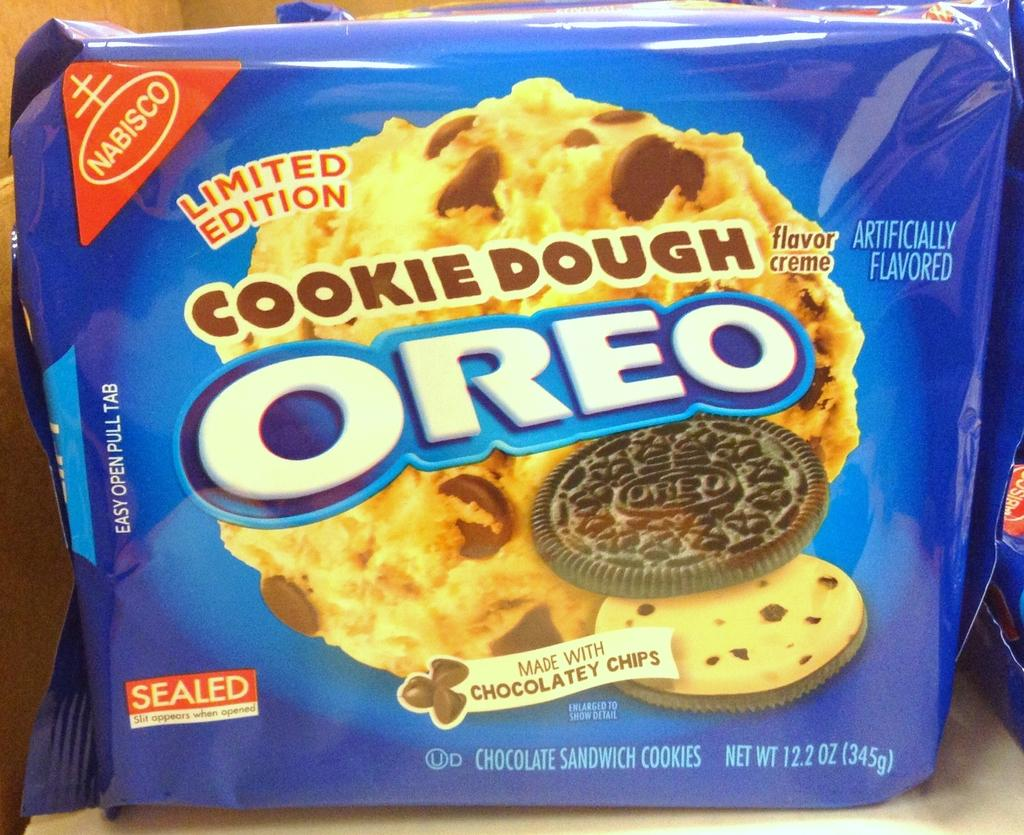What is: What is the main subject of the image? The main subject of the image is an Oreo biscuit packet. How is the packet positioned in the image? The packet is placed on a surface. What can be seen on the packet besides the text? There is a picture of a biscuit on the packet. What information might be conveyed through the text on the packet? The text on the packet could provide details about the product, such as ingredients, nutritional information, or branding. What type of wine is being advertised on the Oreo biscuit packet? There is no wine being advertised on the Oreo biscuit packet; it is a packet of biscuits. How many pears are visible on the Oreo biscuit packet? There are no pears visible on the Oreo bisc biscuit packet; it features a picture of a biscuit. 